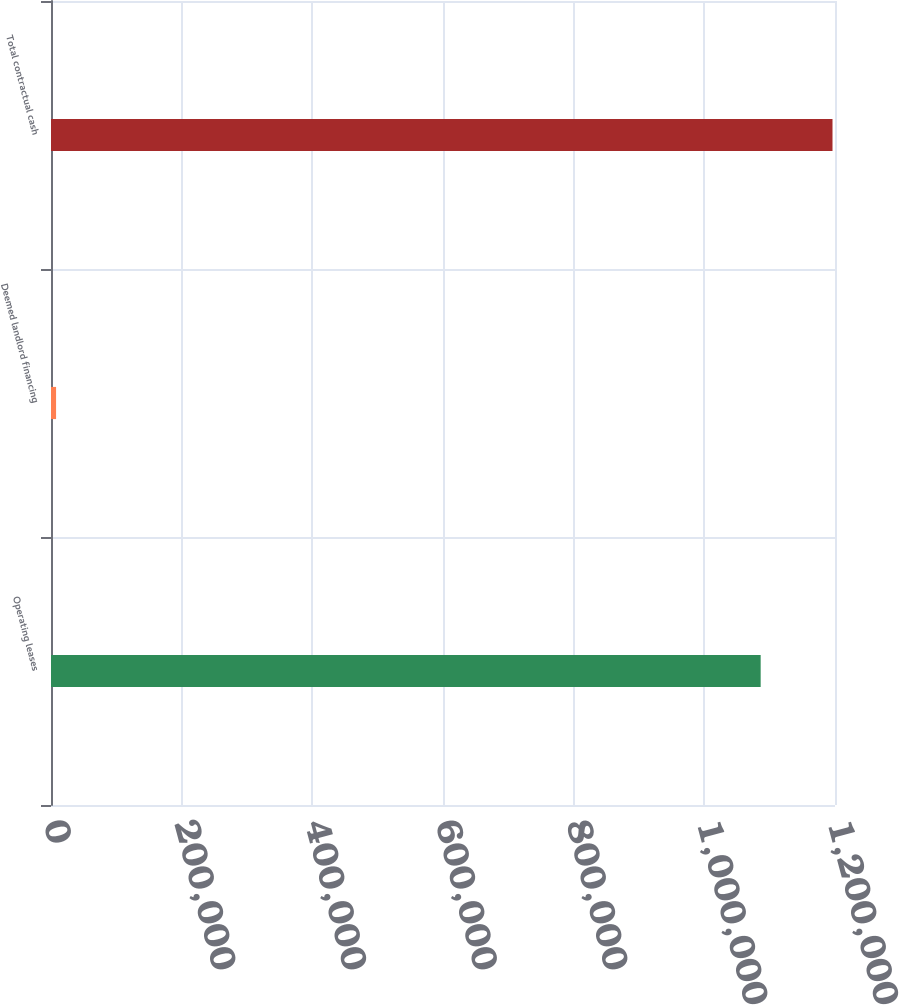Convert chart. <chart><loc_0><loc_0><loc_500><loc_500><bar_chart><fcel>Operating leases<fcel>Deemed landlord financing<fcel>Total contractual cash<nl><fcel>1.08622e+06<fcel>7756<fcel>1.19618e+06<nl></chart> 